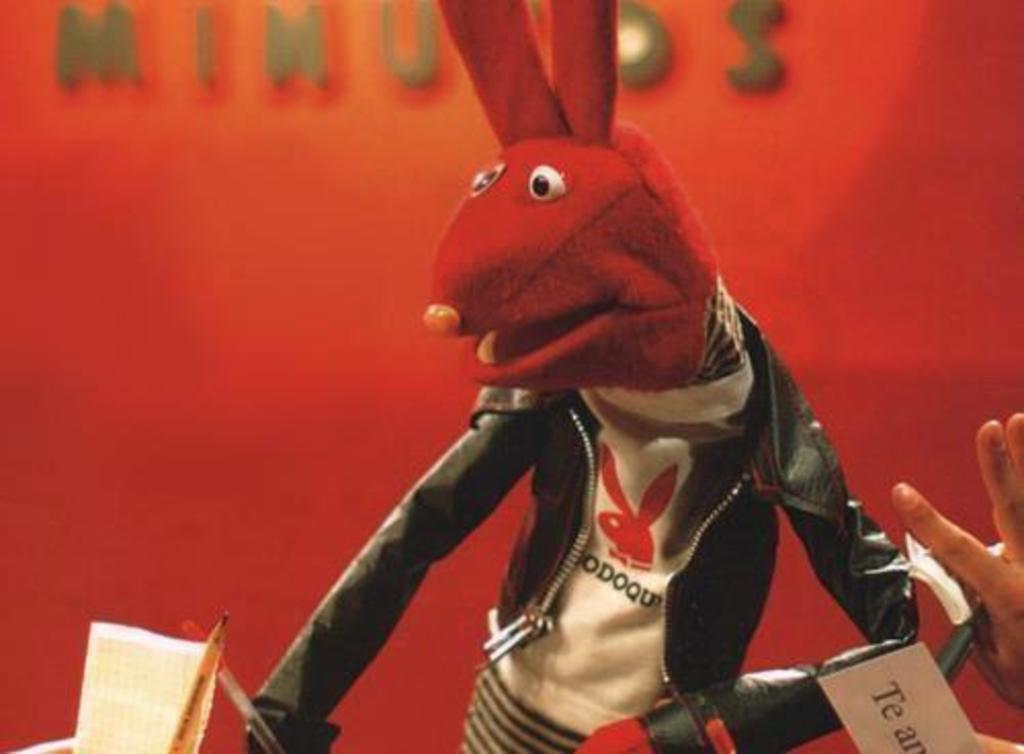Please provide a concise description of this image. In the center of the image we can see a cartoon. At the bottom there is a mic. In the background is a wall and we can see a board. 